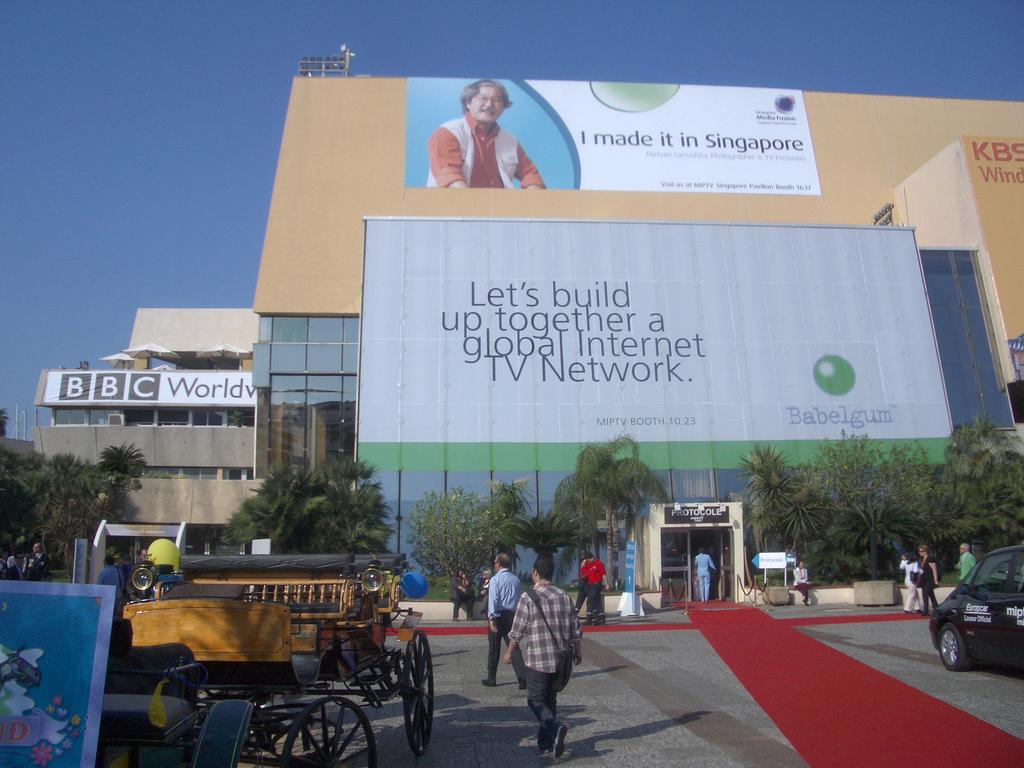<image>
Render a clear and concise summary of the photo. Billboard that says "Let's build up together" outdoors on a sunny day. 